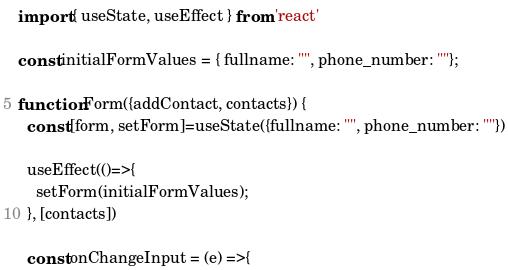<code> <loc_0><loc_0><loc_500><loc_500><_JavaScript_>import { useState, useEffect } from 'react'

const initialFormValues = { fullname: "", phone_number: ""};

function Form({addContact, contacts}) {  
  const [form, setForm]=useState({fullname: "", phone_number: ""})
  
  useEffect(()=>{
    setForm(initialFormValues);
  }, [contacts])

  const onChangeInput = (e) =>{</code> 